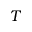<formula> <loc_0><loc_0><loc_500><loc_500>T</formula> 